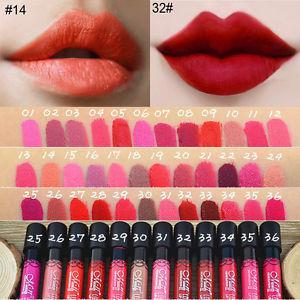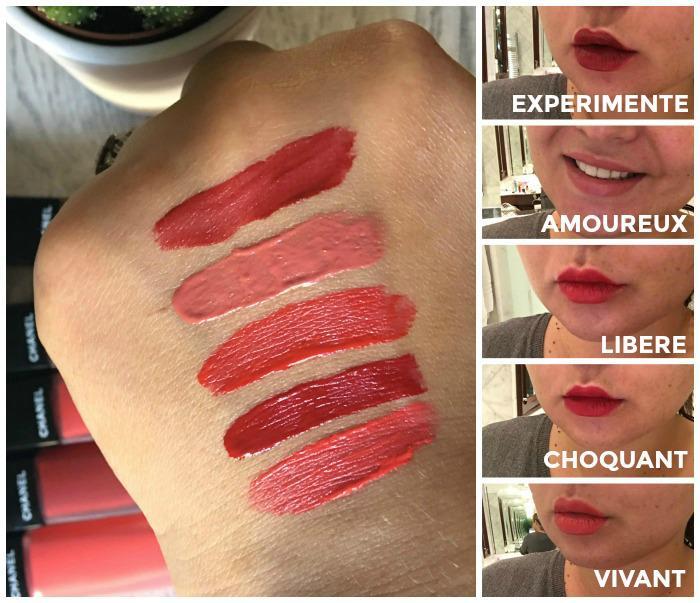The first image is the image on the left, the second image is the image on the right. For the images displayed, is the sentence "Tinted lips and smears of different lipstick colors are shown, along with containers of lip makeup." factually correct? Answer yes or no. Yes. 